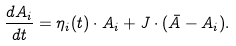<formula> <loc_0><loc_0><loc_500><loc_500>\frac { d A _ { i } } { d t } = \eta _ { i } ( t ) \cdot A _ { i } + J \cdot ( \bar { A } - A _ { i } ) .</formula> 